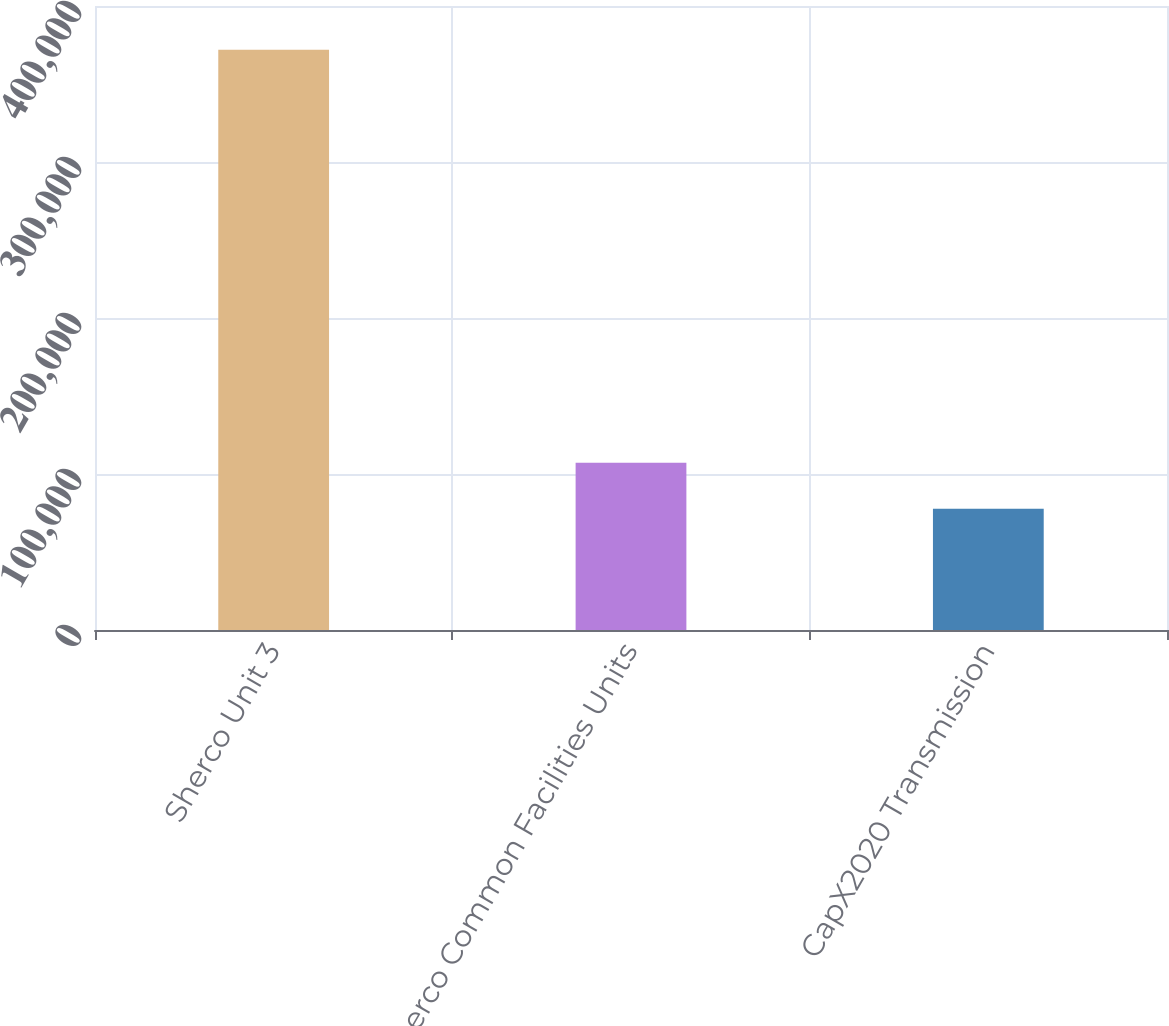<chart> <loc_0><loc_0><loc_500><loc_500><bar_chart><fcel>Sherco Unit 3<fcel>Sherco Common Facilities Units<fcel>CapX2020 Transmission<nl><fcel>371925<fcel>107215<fcel>77803<nl></chart> 